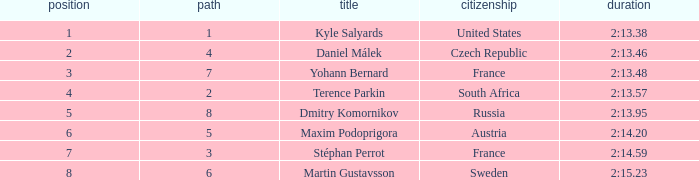What was Maxim Podoprigora's lowest rank? 6.0. 